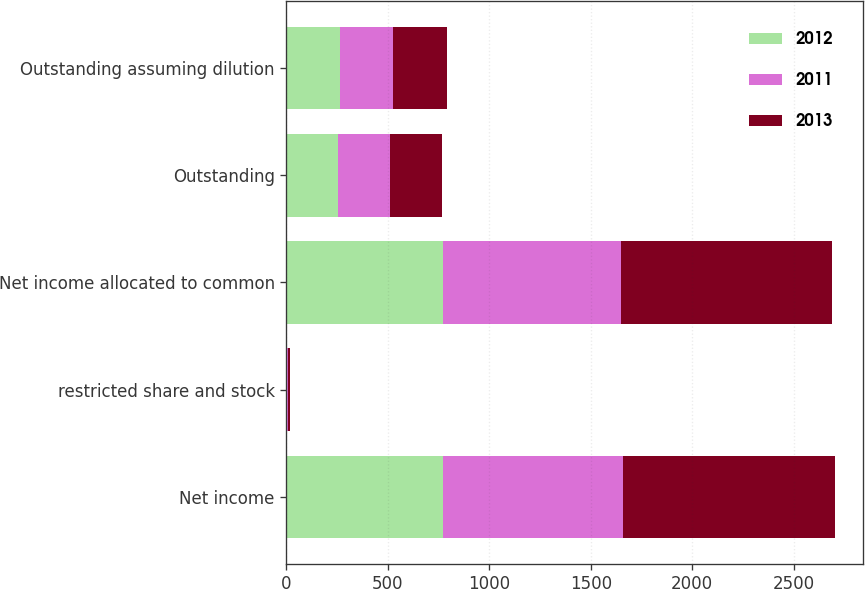Convert chart to OTSL. <chart><loc_0><loc_0><loc_500><loc_500><stacked_bar_chart><ecel><fcel>Net income<fcel>restricted share and stock<fcel>Net income allocated to common<fcel>Outstanding<fcel>Outstanding assuming dilution<nl><fcel>2012<fcel>773.2<fcel>3.5<fcel>769.7<fcel>255.6<fcel>263.3<nl><fcel>2011<fcel>883.6<fcel>5.5<fcel>878.1<fcel>253.4<fcel>261<nl><fcel>2013<fcel>1047.7<fcel>9.3<fcel>1038.4<fcel>258.3<fcel>266.3<nl></chart> 